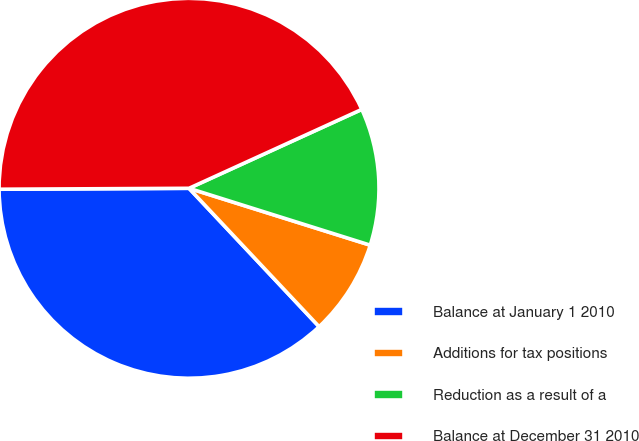Convert chart. <chart><loc_0><loc_0><loc_500><loc_500><pie_chart><fcel>Balance at January 1 2010<fcel>Additions for tax positions<fcel>Reduction as a result of a<fcel>Balance at December 31 2010<nl><fcel>36.93%<fcel>8.15%<fcel>11.66%<fcel>43.26%<nl></chart> 